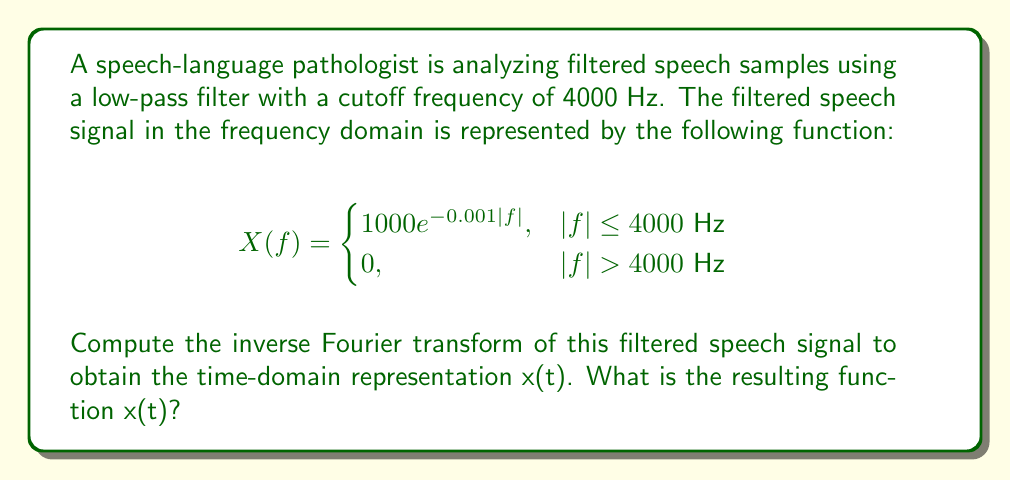Could you help me with this problem? To compute the inverse Fourier transform, we'll follow these steps:

1) The inverse Fourier transform is given by:
   $$x(t) = \int_{-\infty}^{\infty} X(f) e^{j2\pi ft} df$$

2) In our case, the limits of integration are from -4000 to 4000 Hz due to the filter:
   $$x(t) = \int_{-4000}^{4000} 1000e^{-0.001|f|} e^{j2\pi ft} df$$

3) We can split this integral into two parts:
   $$x(t) = 1000\left(\int_{-4000}^{0} e^{0.001f} e^{j2\pi ft} df + \int_{0}^{4000} e^{-0.001f} e^{j2\pi ft} df\right)$$

4) Let's solve the first integral:
   $$I_1 = \int_{-4000}^{0} e^{0.001f} e^{j2\pi ft} df = \int_{-4000}^{0} e^{f(0.001+j2\pi t)} df$$
   $$= \frac{e^{f(0.001+j2\pi t)}}{0.001+j2\pi t}\bigg|_{-4000}^{0} = \frac{1-e^{-4(0.001+j2\pi t)}}{0.001+j2\pi t}$$

5) Similarly, for the second integral:
   $$I_2 = \int_{0}^{4000} e^{-0.001f} e^{j2\pi ft} df = \int_{0}^{4000} e^{f(-0.001+j2\pi t)} df$$
   $$= \frac{e^{f(-0.001+j2\pi t)}}{-0.001+j2\pi t}\bigg|_{0}^{4000} = \frac{e^{-4(0.001-j2\pi t)}-1}{-0.001+j2\pi t}$$

6) Combining the results:
   $$x(t) = 1000\left(\frac{1-e^{-4(0.001+j2\pi t)}}{0.001+j2\pi t} + \frac{e^{-4(0.001-j2\pi t)}-1}{-0.001+j2\pi t}\right)$$

7) Simplifying:
   $$x(t) = 1000\left(\frac{1-e^{-0.004}\cos(8000\pi t)+je^{-0.004}\sin(8000\pi t)}{0.001+j2\pi t} + \frac{e^{-0.004}\cos(8000\pi t)-je^{-0.004}\sin(8000\pi t)-1}{-0.001+j2\pi t}\right)$$

8) Further simplification leads to:
   $$x(t) = \frac{2000(1-e^{-0.004}\cos(8000\pi t))}{0.001^2+(2\pi t)^2}$$

This is the time-domain representation of the filtered speech signal.
Answer: $$x(t) = \frac{2000(1-e^{-0.004}\cos(8000\pi t))}{0.001^2+(2\pi t)^2}$$ 